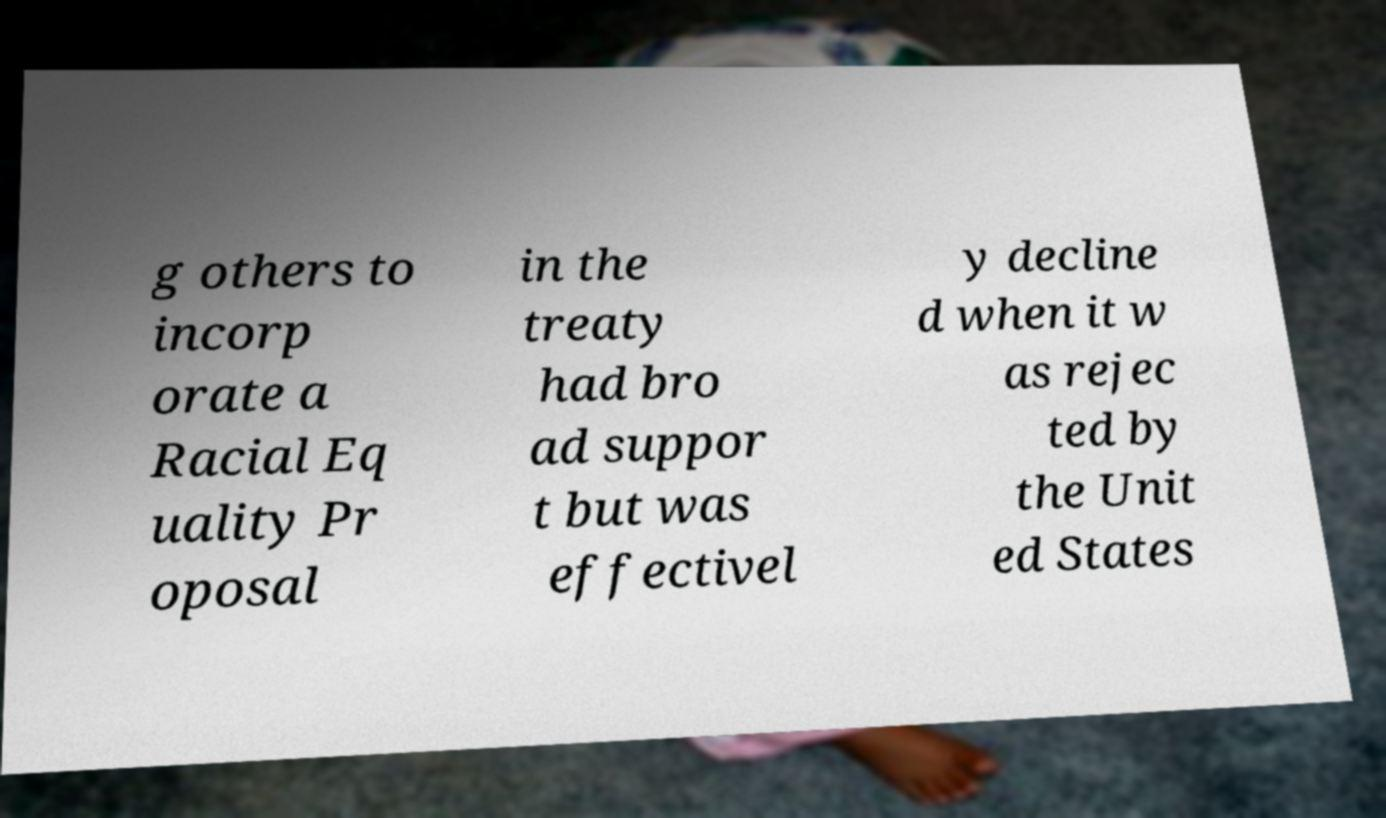I need the written content from this picture converted into text. Can you do that? g others to incorp orate a Racial Eq uality Pr oposal in the treaty had bro ad suppor t but was effectivel y decline d when it w as rejec ted by the Unit ed States 